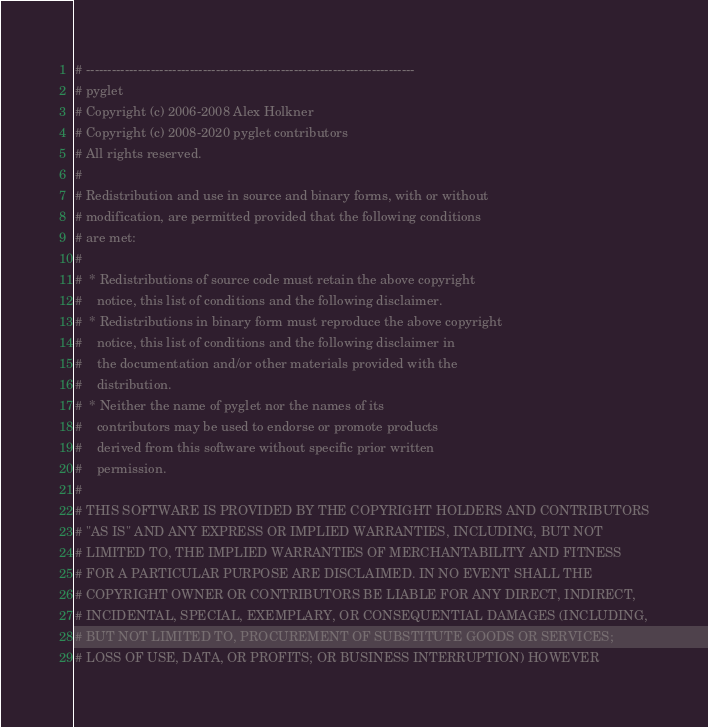<code> <loc_0><loc_0><loc_500><loc_500><_Python_># ----------------------------------------------------------------------------
# pyglet
# Copyright (c) 2006-2008 Alex Holkner
# Copyright (c) 2008-2020 pyglet contributors
# All rights reserved.
#
# Redistribution and use in source and binary forms, with or without
# modification, are permitted provided that the following conditions
# are met:
#
#  * Redistributions of source code must retain the above copyright
#    notice, this list of conditions and the following disclaimer.
#  * Redistributions in binary form must reproduce the above copyright
#    notice, this list of conditions and the following disclaimer in
#    the documentation and/or other materials provided with the
#    distribution.
#  * Neither the name of pyglet nor the names of its
#    contributors may be used to endorse or promote products
#    derived from this software without specific prior written
#    permission.
#
# THIS SOFTWARE IS PROVIDED BY THE COPYRIGHT HOLDERS AND CONTRIBUTORS
# "AS IS" AND ANY EXPRESS OR IMPLIED WARRANTIES, INCLUDING, BUT NOT
# LIMITED TO, THE IMPLIED WARRANTIES OF MERCHANTABILITY AND FITNESS
# FOR A PARTICULAR PURPOSE ARE DISCLAIMED. IN NO EVENT SHALL THE
# COPYRIGHT OWNER OR CONTRIBUTORS BE LIABLE FOR ANY DIRECT, INDIRECT,
# INCIDENTAL, SPECIAL, EXEMPLARY, OR CONSEQUENTIAL DAMAGES (INCLUDING,
# BUT NOT LIMITED TO, PROCUREMENT OF SUBSTITUTE GOODS OR SERVICES;
# LOSS OF USE, DATA, OR PROFITS; OR BUSINESS INTERRUPTION) HOWEVER</code> 